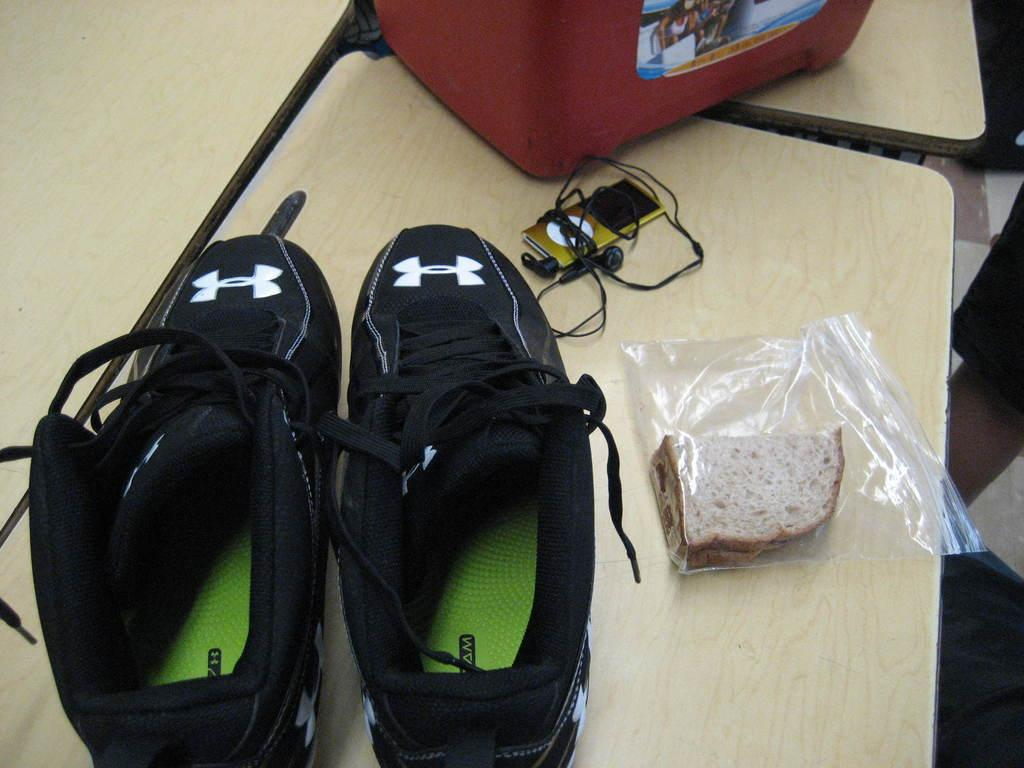What objects are placed on the table in the image? There are shoes on the table in the image. What type of food item is present in the image? There are breads in a packet in the image. What electronic device can be seen in the image? There is an iPod in the image. How are the earphones positioned in relation to the iPod? Earphones are tied around the iPod in the image. How does the heart rate of the person in the image change when they see the police? There is no person or police visible in the image, so it is not possible to determine any changes in heart rate. 